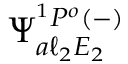Convert formula to latex. <formula><loc_0><loc_0><loc_500><loc_500>\Psi _ { a \ell _ { 2 } E _ { 2 } } ^ { { ^ { 1 } P ^ { o } } ( - ) }</formula> 